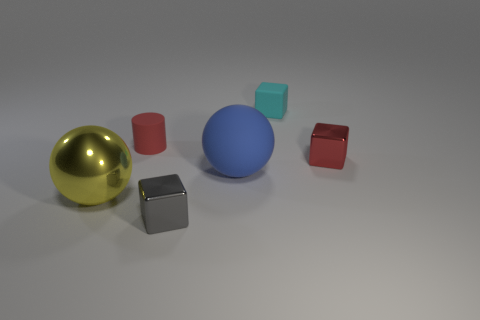Is the size of the red rubber object the same as the blue matte thing? No, the red rubber object, which is cylindrical in shape, is smaller in height compared to the blue matte ball. The blue ball appears to have a larger volume overall, indicating that their sizes are not the same. 